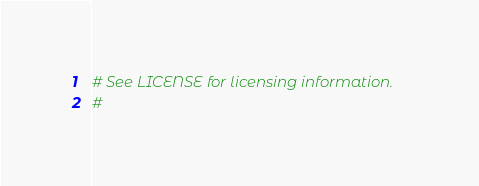<code> <loc_0><loc_0><loc_500><loc_500><_Python_># See LICENSE for licensing information.
#</code> 